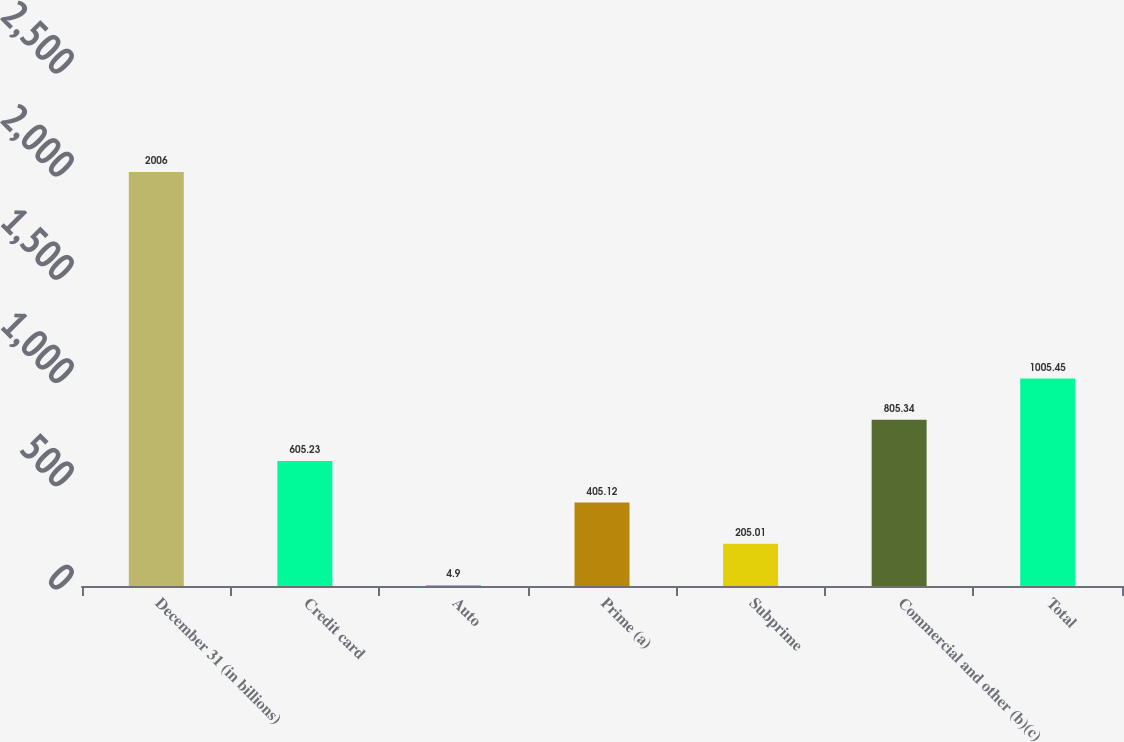<chart> <loc_0><loc_0><loc_500><loc_500><bar_chart><fcel>December 31 (in billions)<fcel>Credit card<fcel>Auto<fcel>Prime (a)<fcel>Subprime<fcel>Commercial and other (b)(c)<fcel>Total<nl><fcel>2006<fcel>605.23<fcel>4.9<fcel>405.12<fcel>205.01<fcel>805.34<fcel>1005.45<nl></chart> 